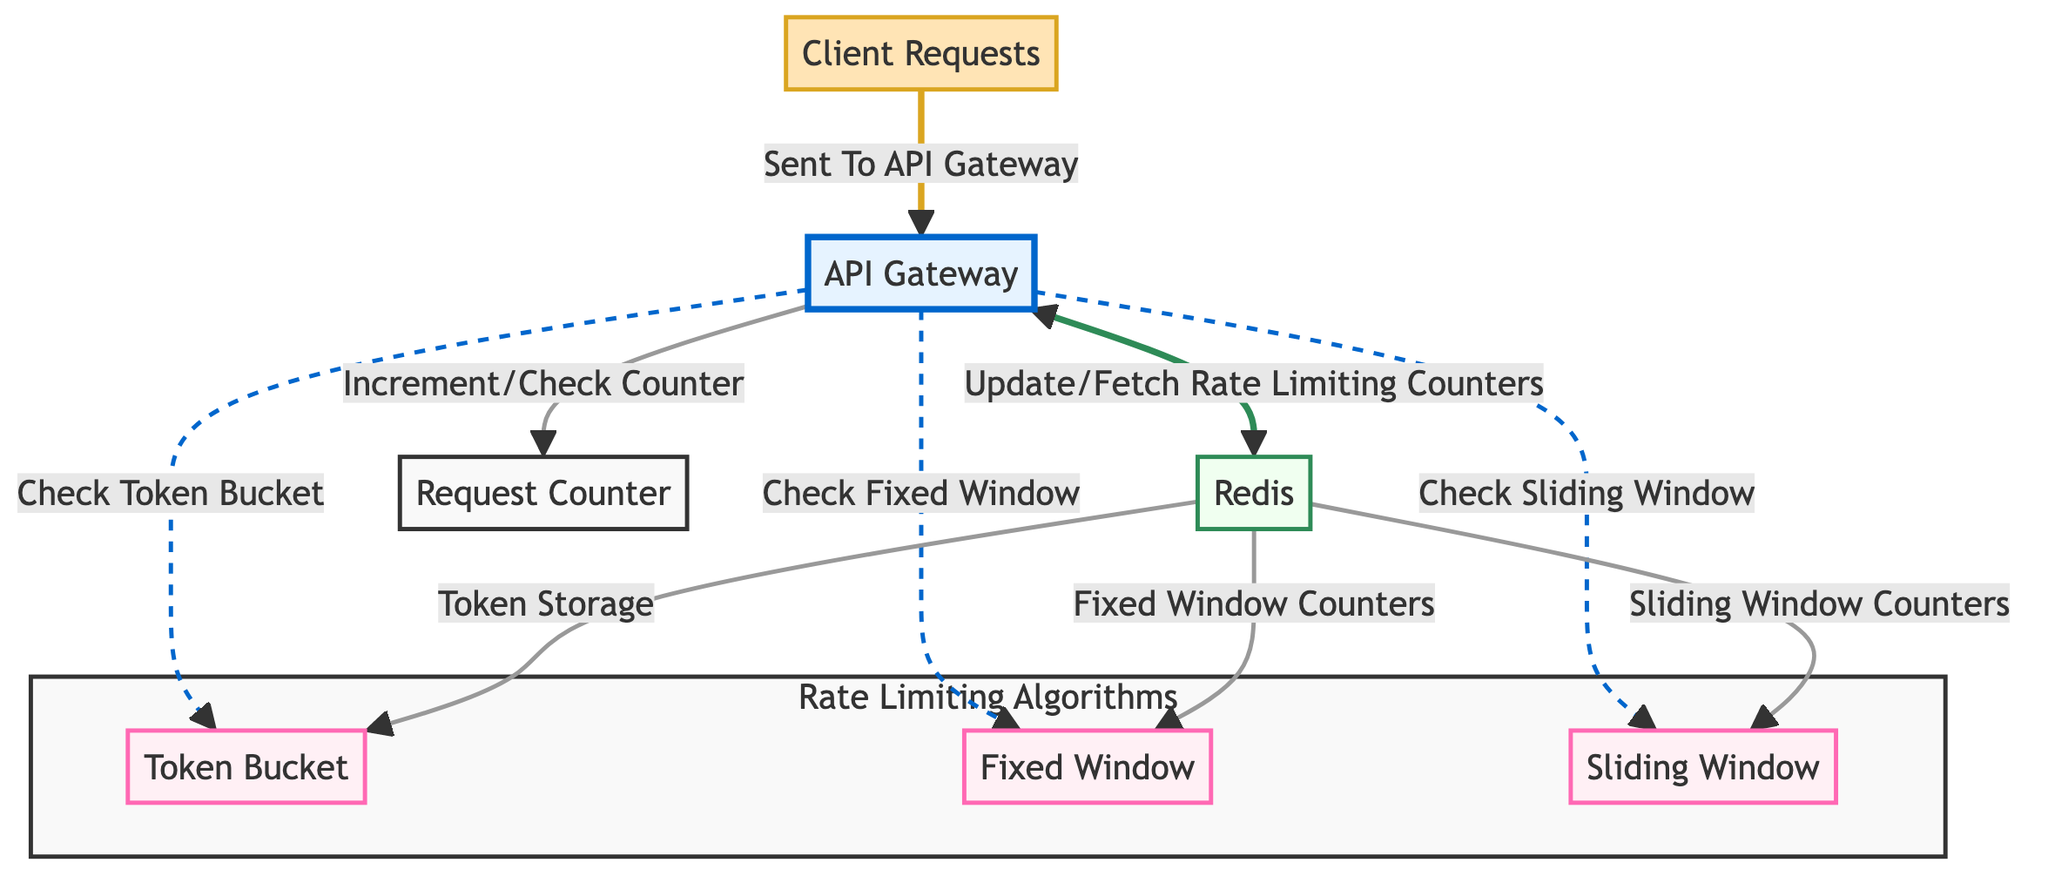What is the first step when a client sends a request? The diagram shows that when a client sends a request, the first step is to send it to the API Gateway. The arrow indicates the flow from the "Client Requests" node to the "API Gateway" node.
Answer: API Gateway How many rate limiting algorithms are presented in the diagram? The diagram includes three rate limiting algorithms: Token Bucket, Fixed Window, and Sliding Window. Each algorithm is represented as a separate node connected to the API Gateway.
Answer: Three What is the storage system used for counters and tokens? The diagram shows that Redis is the storage system used for managing the Token Storage, Fixed Window Counters, and Sliding Window Counters. The "Redis" node connects to each of these components.
Answer: Redis What does the API Gateway do after checking the rate limiting algorithms? After checking the rate limiting algorithms, the API Gateway updates or fetches rate limiting counters, as indicated by the connection returning to the "API Gateway" from the "Update/Fetch Rate Limiting Counters" node.
Answer: Update/Fetch Rate Limiting Counters Which algorithm has a direct connection for token storage? The Token Bucket algorithm has a direct connection to Redis for token storage, as the diagram shows a flow from the "Redis" node to the "Token Bucket" node.
Answer: Token Bucket What color represents the API Gateway in the diagram? According to the color coding in the diagram, the API Gateway is represented with a light blue fill and a blue stroke. This can be seen at the corresponding node identified as "API Gateway."
Answer: Light blue Which algorithm checks or increments its counter after the API Gateway? The Request Counter is connected to the API Gateway, showing that it checks or increments its counter after processing input from the different rate limiting algorithms.
Answer: Request Counter How does the client interact with the API Gateway? The client sends requests to the API Gateway, which is indicated by the directed arrow showing the flow from the "Client Requests" to the "API Gateway." The arrow signifies the interaction or communication path.
Answer: Sends requests to Which node represents the sliding window algorithm? The Sliding Window node represents the sliding window algorithm, which can be recognized by its label in the diagram. It is also distinguished by its color coding as an algorithm.
Answer: Sliding Window 